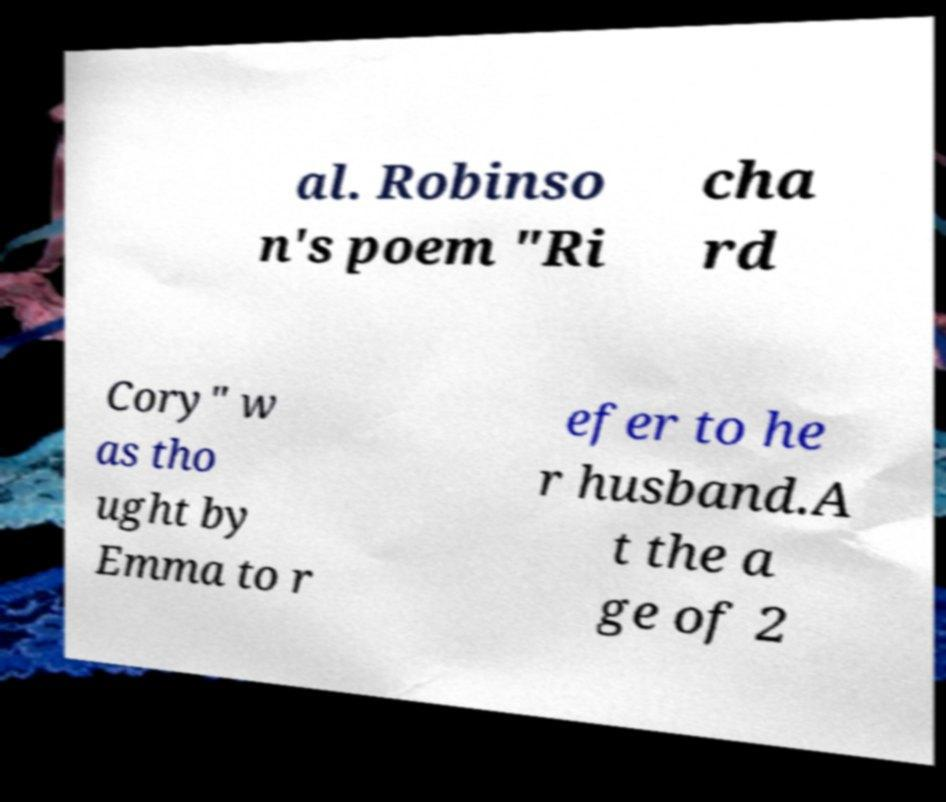What messages or text are displayed in this image? I need them in a readable, typed format. al. Robinso n's poem "Ri cha rd Cory" w as tho ught by Emma to r efer to he r husband.A t the a ge of 2 